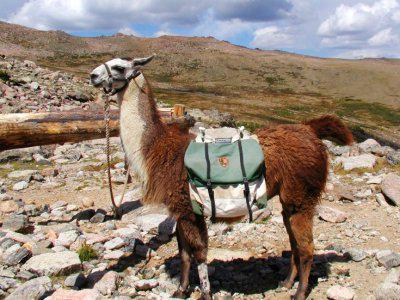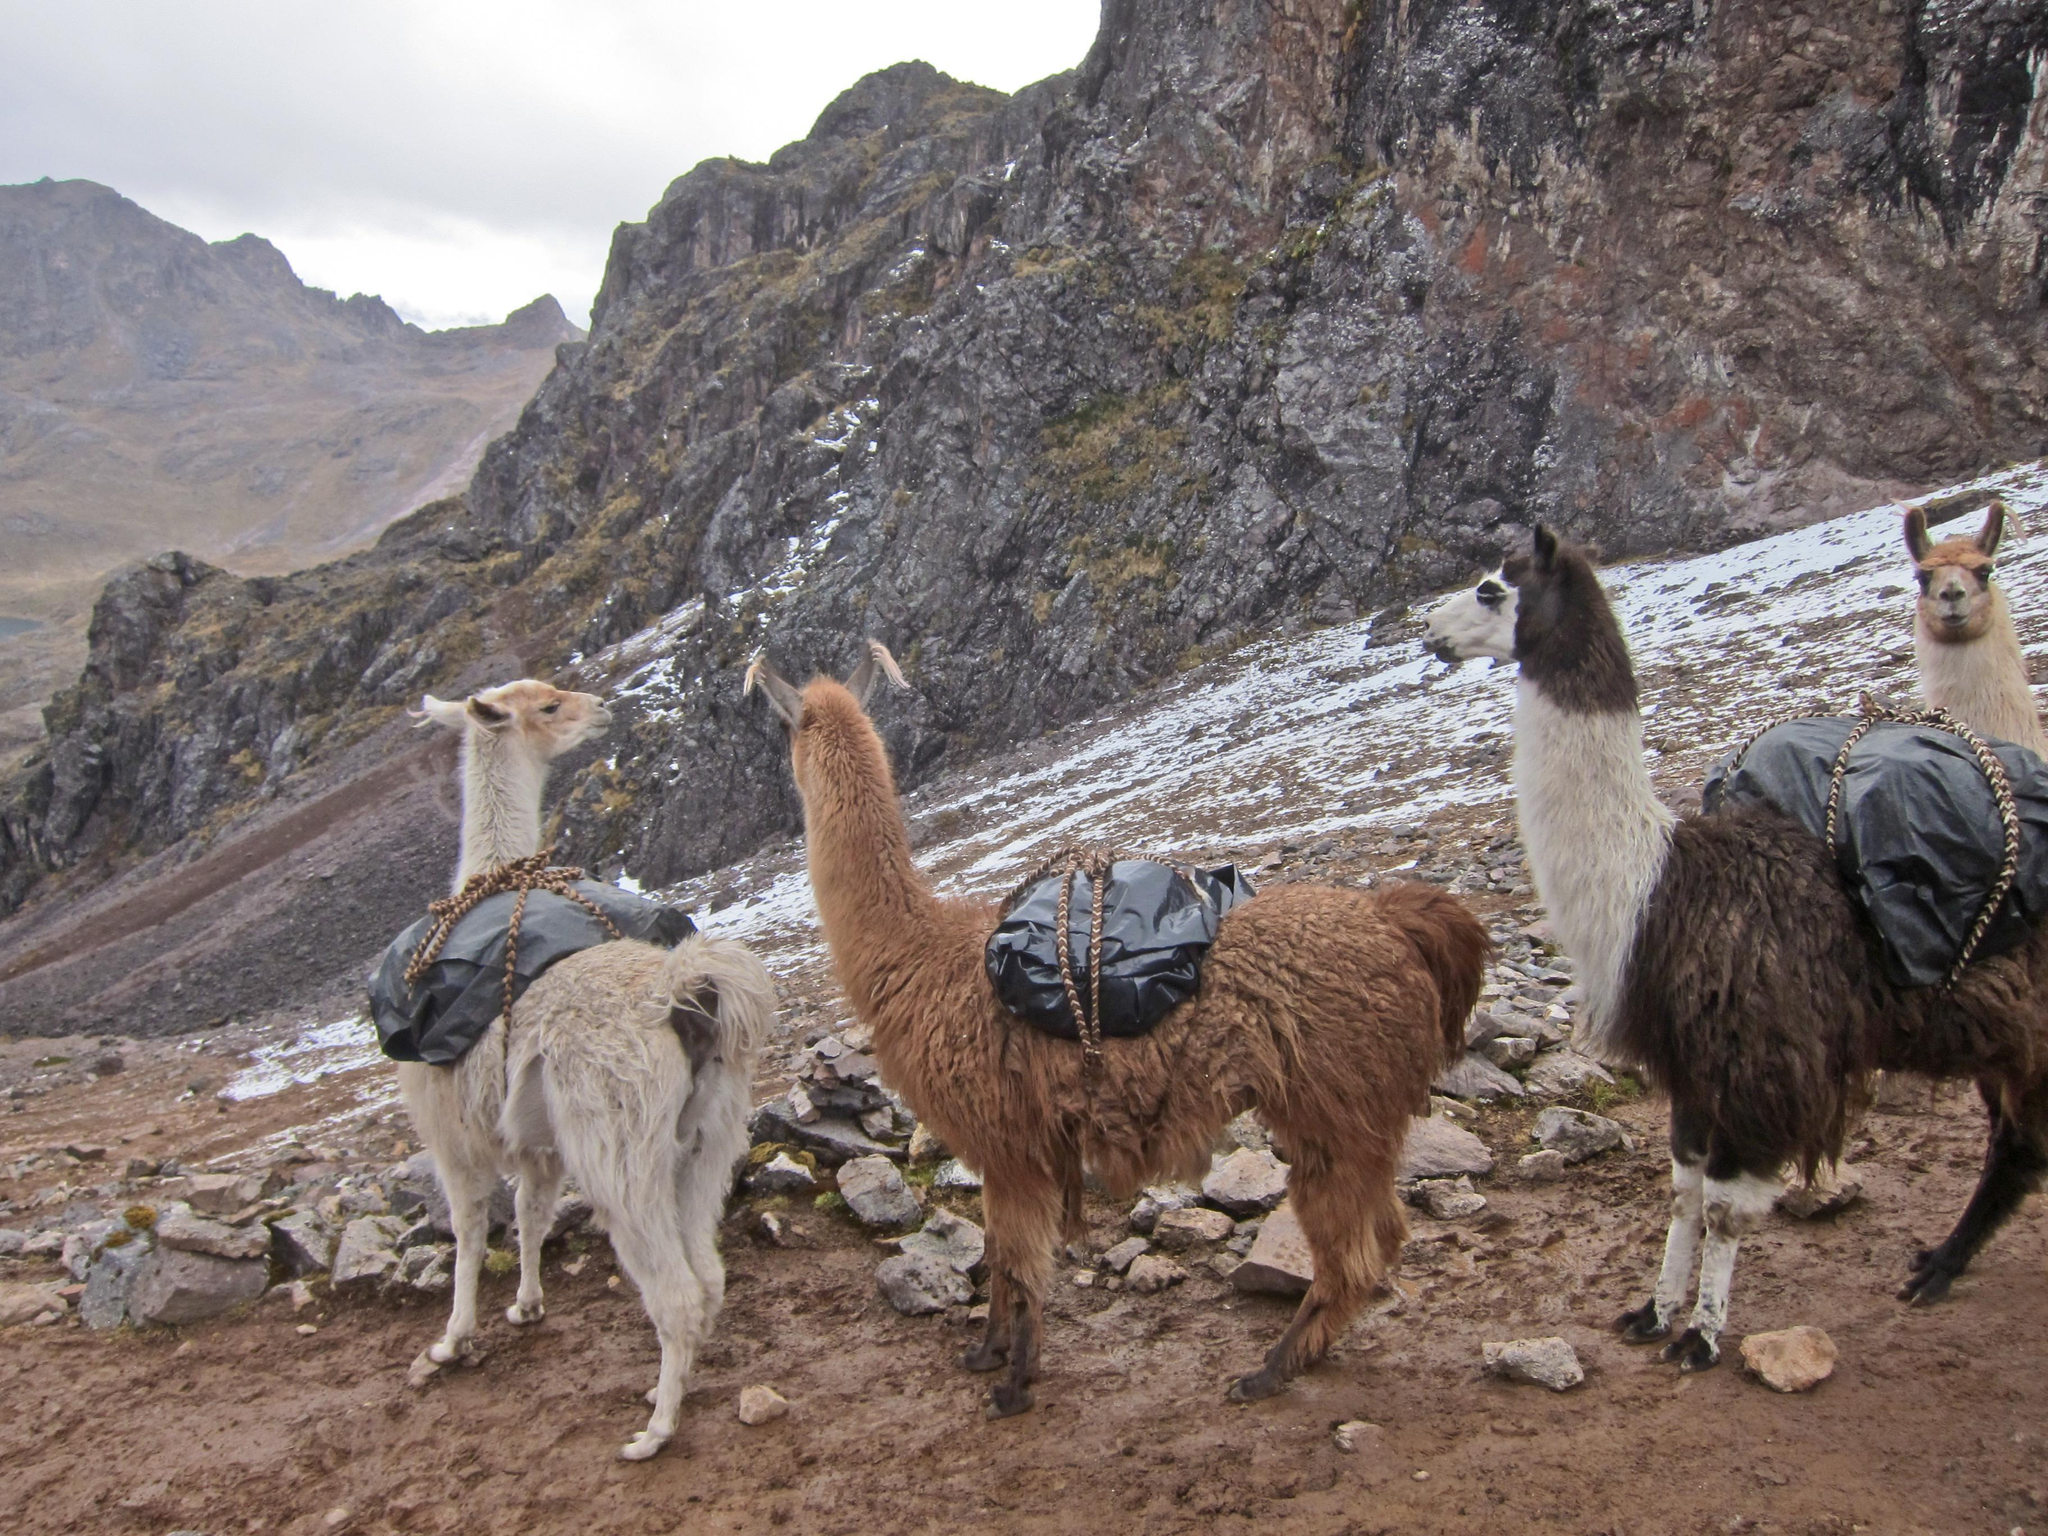The first image is the image on the left, the second image is the image on the right. Given the left and right images, does the statement "In one of the images the llamas are facing downhill." hold true? Answer yes or no. Yes. 